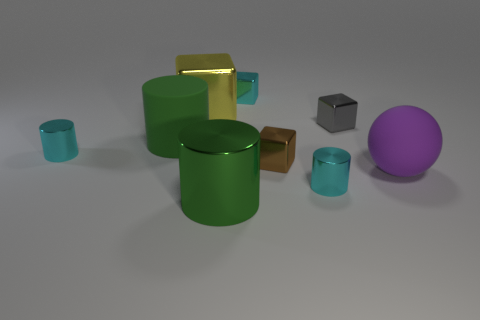What shapes are present in the image and which is the most abundant? The shapes present are cylinders, cubes, and a sphere. The most abundant shape is the cylinder, with three instances. 